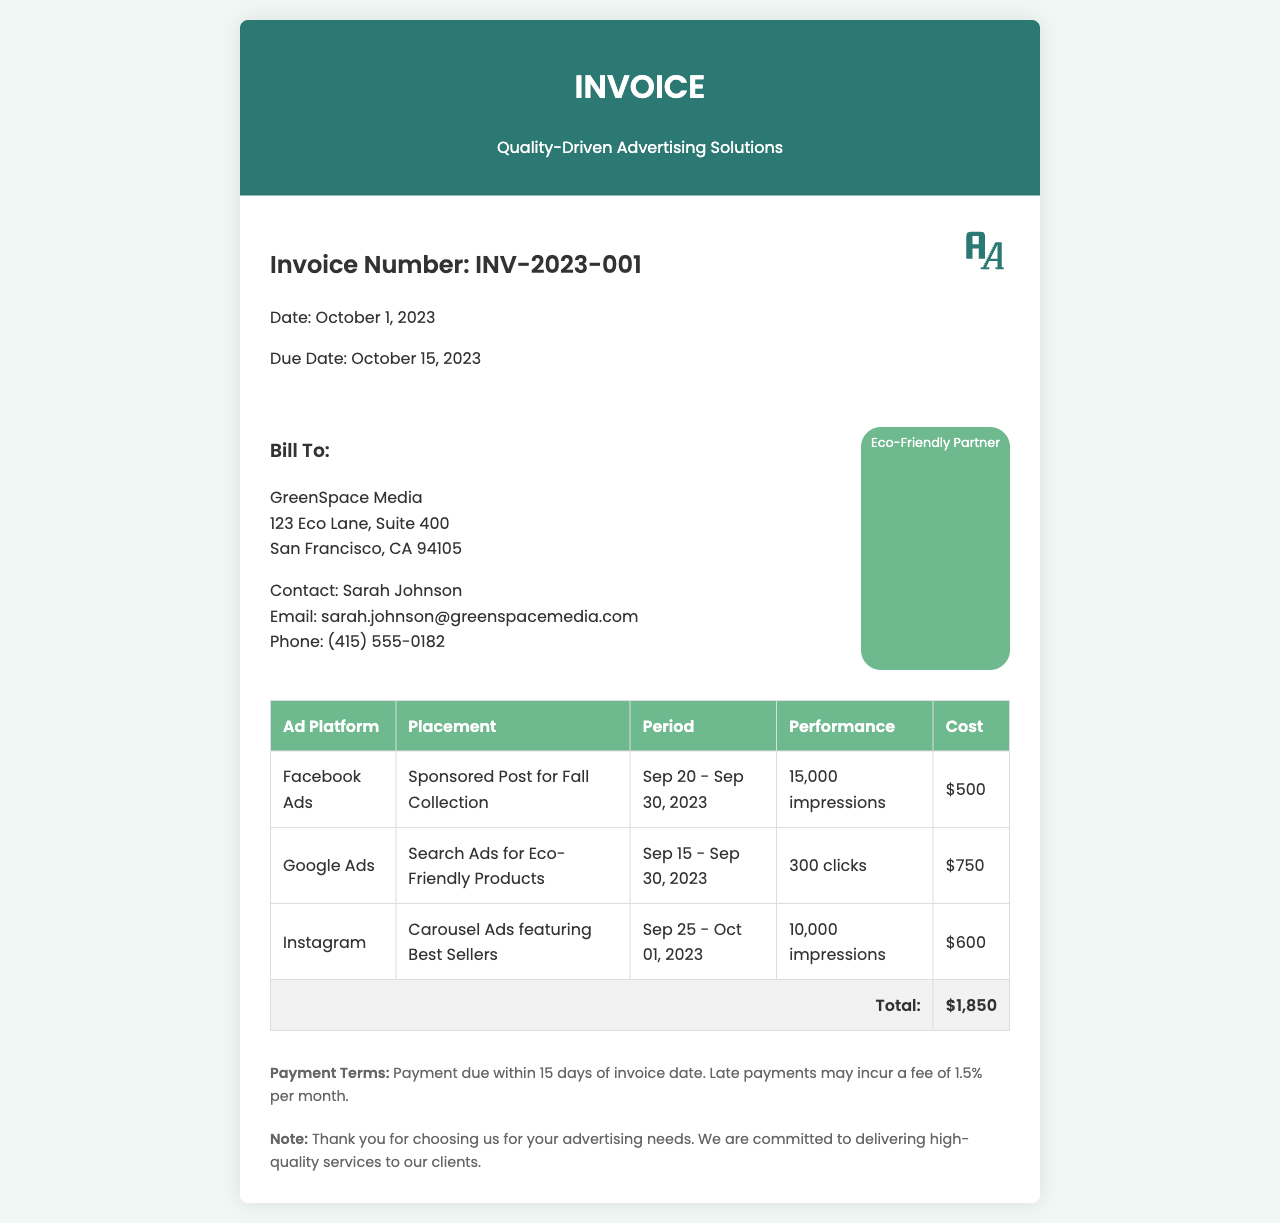What is the invoice number? The invoice number is clearly stated at the top of the document.
Answer: INV-2023-001 What is the total cost of the advertising campaign? The total cost can be found at the bottom of the table, summing the individual costs.
Answer: $1,850 When is the due date for this invoice? The due date is mentioned in the invoice details section.
Answer: October 15, 2023 Who is the contact person at GreenSpace Media? The contact person's name is provided in the client details section.
Answer: Sarah Johnson What platform was used for the Search Ads? The ad platform for the Search Ads can be located in the table under the corresponding row.
Answer: Google Ads What is the payment term for this invoice? The payment term is described in the section towards the end of the invoice.
Answer: Payment due within 15 days of invoice date How many impressions did the Facebook Ads achieve? The performance information is included in the table under the Facebook Ads row.
Answer: 15,000 impressions What type of ads were featured on Instagram? The placement for Instagram is detailed in the table section of the document.
Answer: Carousel Ads featuring Best Sellers What cost is associated with the Google Ads? The cost for Google Ads can be found in the table corresponding to that platform.
Answer: $750 